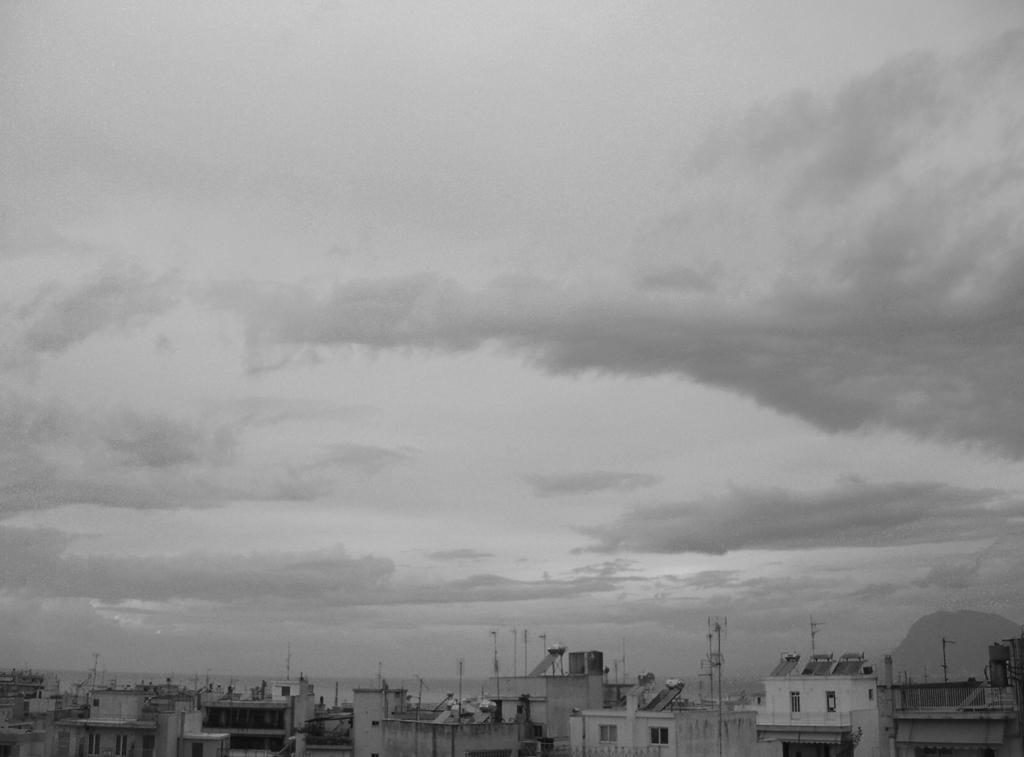What type of structures can be seen in the image? There are buildings in the image. What part of the natural environment is visible in the image? The sky is visible in the background of the image. What type of rake is being used by the beginner in the image? There is no rake or beginner present in the image; it only features buildings and the sky. 